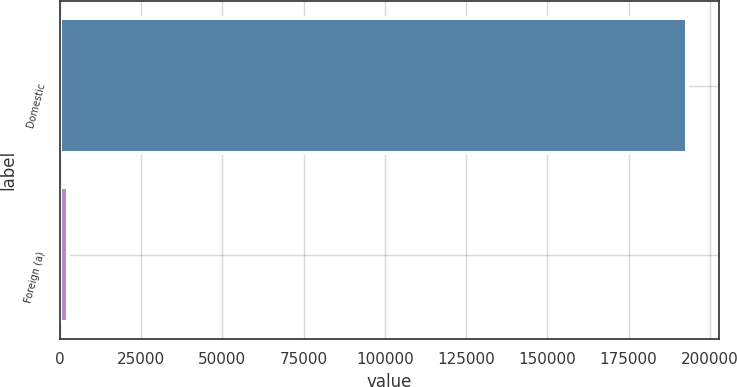<chart> <loc_0><loc_0><loc_500><loc_500><bar_chart><fcel>Domestic<fcel>Foreign (a)<nl><fcel>193055<fcel>2532<nl></chart> 